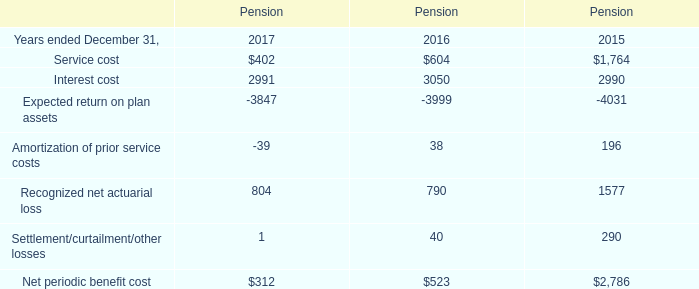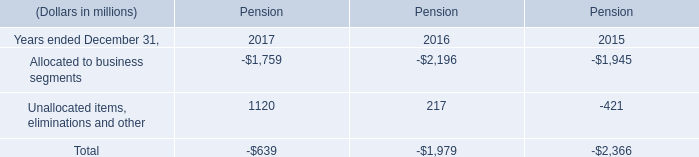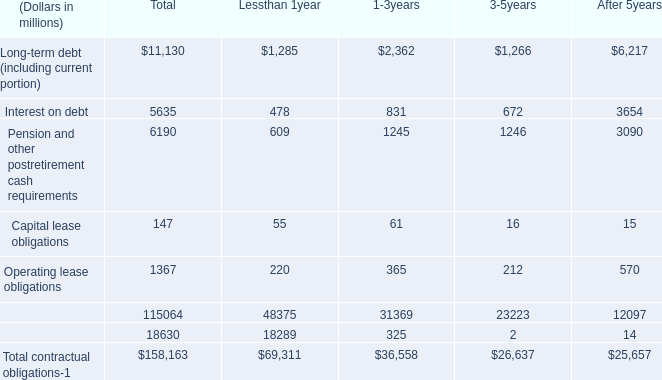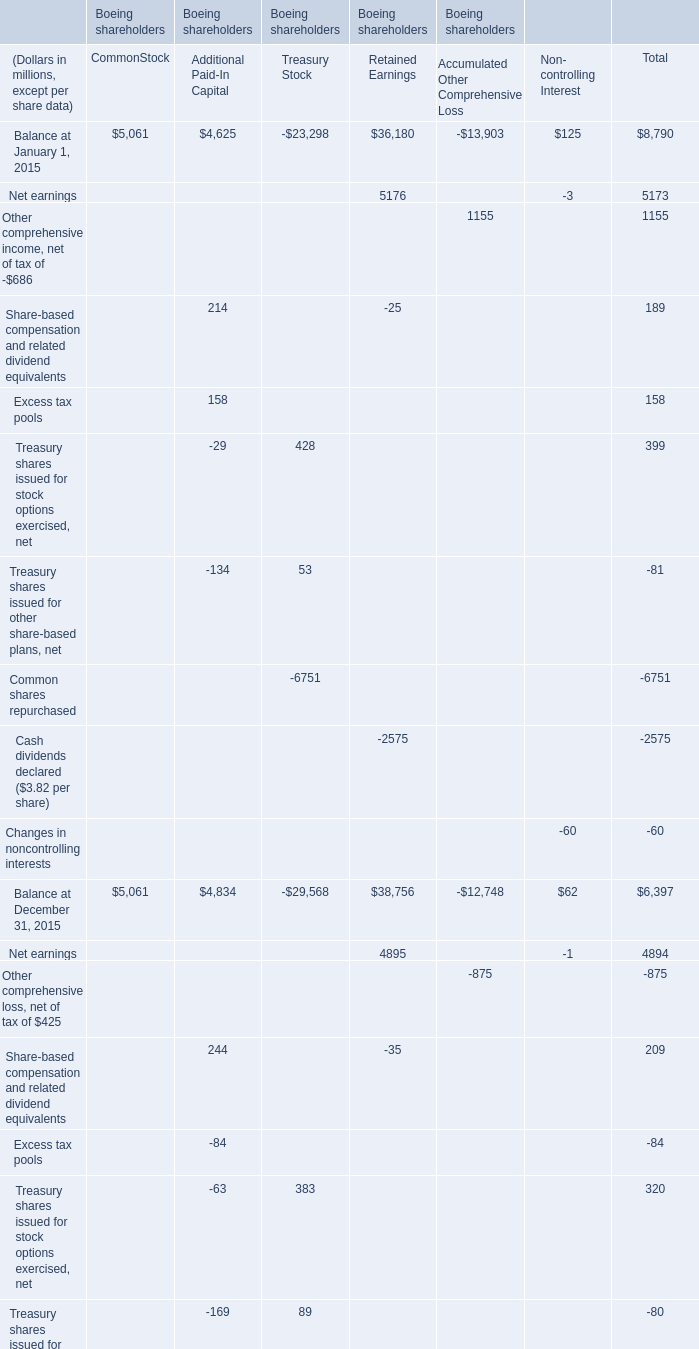How many element exceed the average of Balance at January 1, 2015? 
Computations: (8790 / 6)
Answer: 1465.0. 